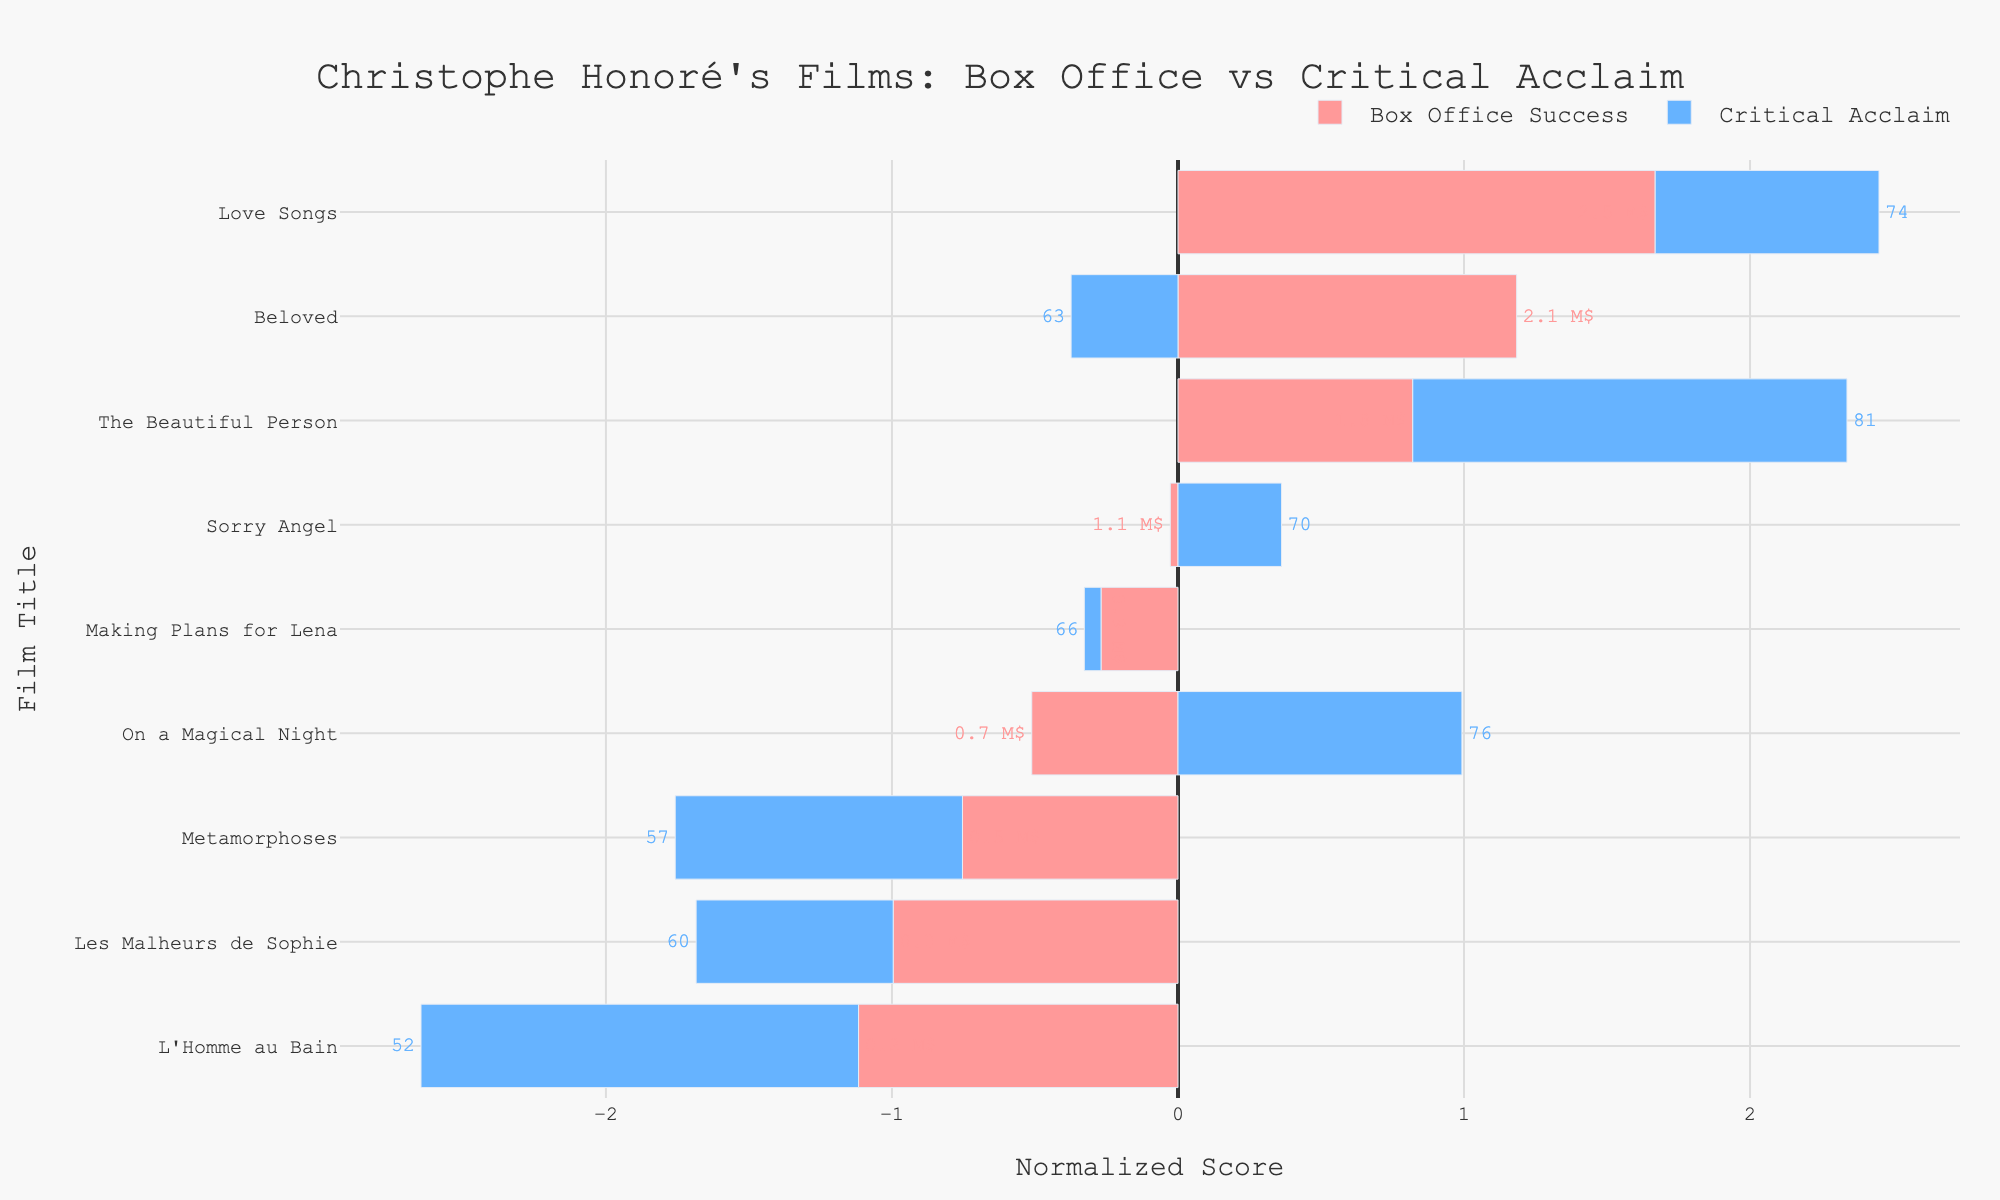Which film has the highest box office success? By visually examining the lengths of the red bars (representing box office success), we can see that "Love Songs" has the longest red bar, indicating the highest box office success.
Answer: "Love Songs" Which film has the highest critical acclaim? By visually examining the lengths of the blue bars (representing critical acclaim), we can see that "The Beautiful Person" has the longest blue bar, indicating the highest critical acclaim.
Answer: "The Beautiful Person" Which film has the lowest box office success? By looking at the red bars, we find that the shortest red bar belongs to "L'Homme au Bain", indicating it has the lowest box office success.
Answer: "L'Homme au Bain" Which film has the lowest critical acclaim? By looking at the blue bars, we find that the shortest blue bar belongs to "L'Homme au Bain", indicating it has the lowest critical acclaim.
Answer: "L'Homme au Bain" What is the difference in normalized box office success between "Love Songs" and "L'Homme au Bain"? The normalized box office success of "Love Songs" is the highest, and the normalized box office success of "L'Homme au Bain" is the lowest. The absolute value of the difference in their normalized scores would be the visual difference in length of the red bars for those films.
Answer: Greatest visual difference How does the critical acclaim of "Sorry Angel" compare to "Beloved"? The blue bar representing "Sorry Angel" is longer than the blue bar representing "Beloved", indicating that "Sorry Angel" has higher critical acclaim.
Answer: "Sorry Angel" > "Beloved" Which films have higher critical acclaim than box office success? By visually comparing the lengths of the blue and red bars for each film, we see that "The Beautiful Person", "Making Plans for Lena", "Les Malheurs de Sophie", and "On a Magical Night" all have longer blue bars than red bars, indicating higher critical acclaim than box office success.
Answer: "The Beautiful Person", "Making Plans for Lena", "Les Malheurs de Sophie", "On a Magical Night" What is the average normalized critical acclaim score for "Love Songs" and "On a Magical Night"? The normalized critical acclaim scores for "Love Songs" and "On a Magical Night" are visually similar when compared to other films. To find the average, we check the blue bar lengths for these two films and average them visually. This step requires seeing their exact values but visually, both seem above average, so their average will also be above the mean value represented by the midpoint baseline.
Answer: Above average Does any film have both the highest box office success and the highest critical acclaim? "Love Songs" has the highest box office success (longest red bar) and "The Beautiful Person" has the highest critical acclaim (longest blue bar). Since these attributes belong to different films, no single film has both the highest box office success and the highest critical acclaim.
Answer: No 